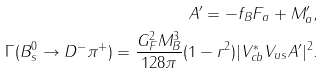<formula> <loc_0><loc_0><loc_500><loc_500>A ^ { \prime } = - f _ { B } F _ { a } + M _ { a } ^ { \prime } , \\ \Gamma ( B _ { s } ^ { 0 } \to D ^ { - } \pi ^ { + } ) = \frac { G _ { F } ^ { 2 } M _ { B } ^ { 3 } } { 1 2 8 \pi } ( 1 - r ^ { 2 } ) | V _ { c b } ^ { * } V _ { u s } A ^ { \prime } | ^ { 2 } .</formula> 